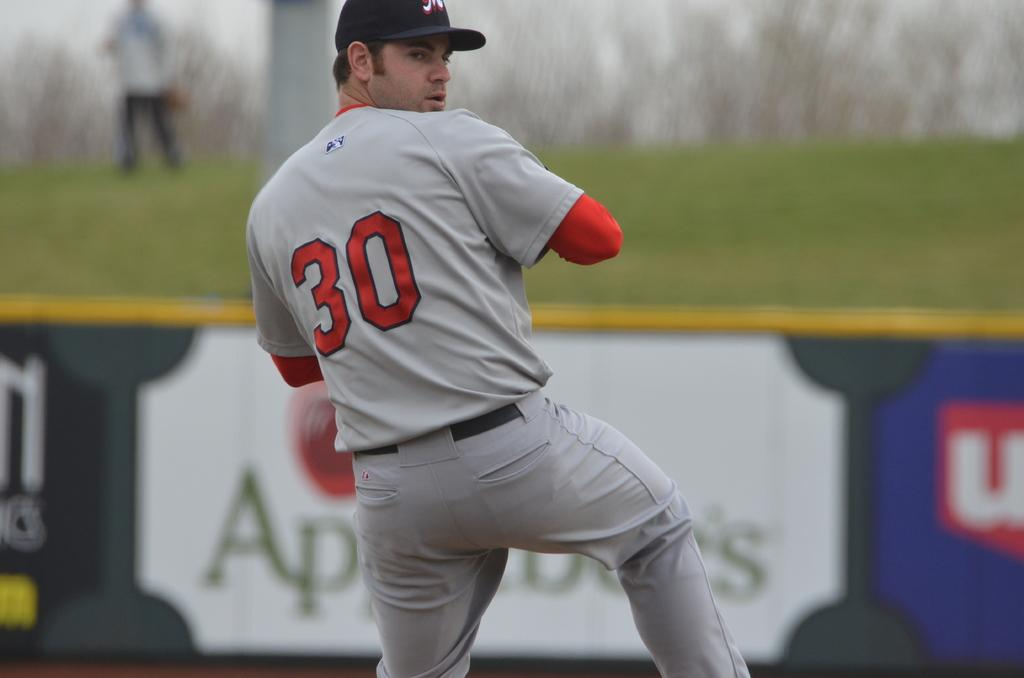<image>
Give a short and clear explanation of the subsequent image. A man with the number 30 on the back of his jersey is playing baseball. 